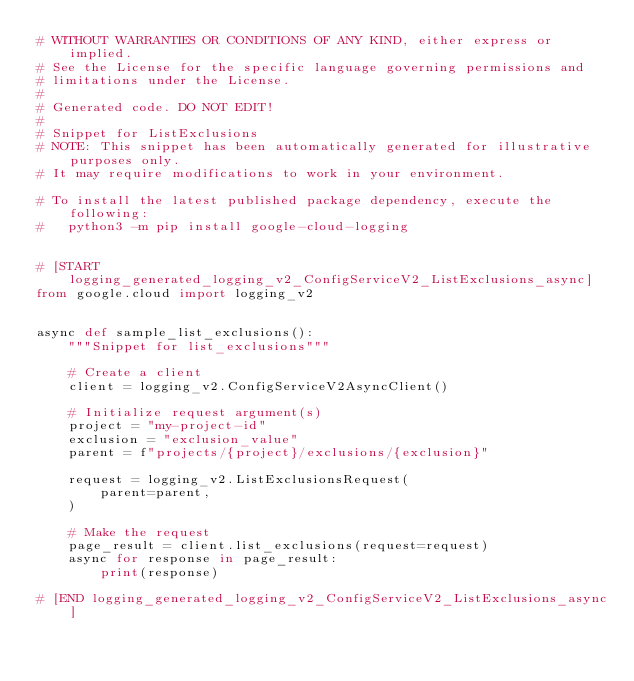Convert code to text. <code><loc_0><loc_0><loc_500><loc_500><_Python_># WITHOUT WARRANTIES OR CONDITIONS OF ANY KIND, either express or implied.
# See the License for the specific language governing permissions and
# limitations under the License.
#
# Generated code. DO NOT EDIT!
#
# Snippet for ListExclusions
# NOTE: This snippet has been automatically generated for illustrative purposes only.
# It may require modifications to work in your environment.

# To install the latest published package dependency, execute the following:
#   python3 -m pip install google-cloud-logging


# [START logging_generated_logging_v2_ConfigServiceV2_ListExclusions_async]
from google.cloud import logging_v2


async def sample_list_exclusions():
    """Snippet for list_exclusions"""

    # Create a client
    client = logging_v2.ConfigServiceV2AsyncClient()

    # Initialize request argument(s)
    project = "my-project-id"
    exclusion = "exclusion_value"
    parent = f"projects/{project}/exclusions/{exclusion}"

    request = logging_v2.ListExclusionsRequest(
        parent=parent,
    )

    # Make the request
    page_result = client.list_exclusions(request=request)
    async for response in page_result:
        print(response)

# [END logging_generated_logging_v2_ConfigServiceV2_ListExclusions_async]
</code> 